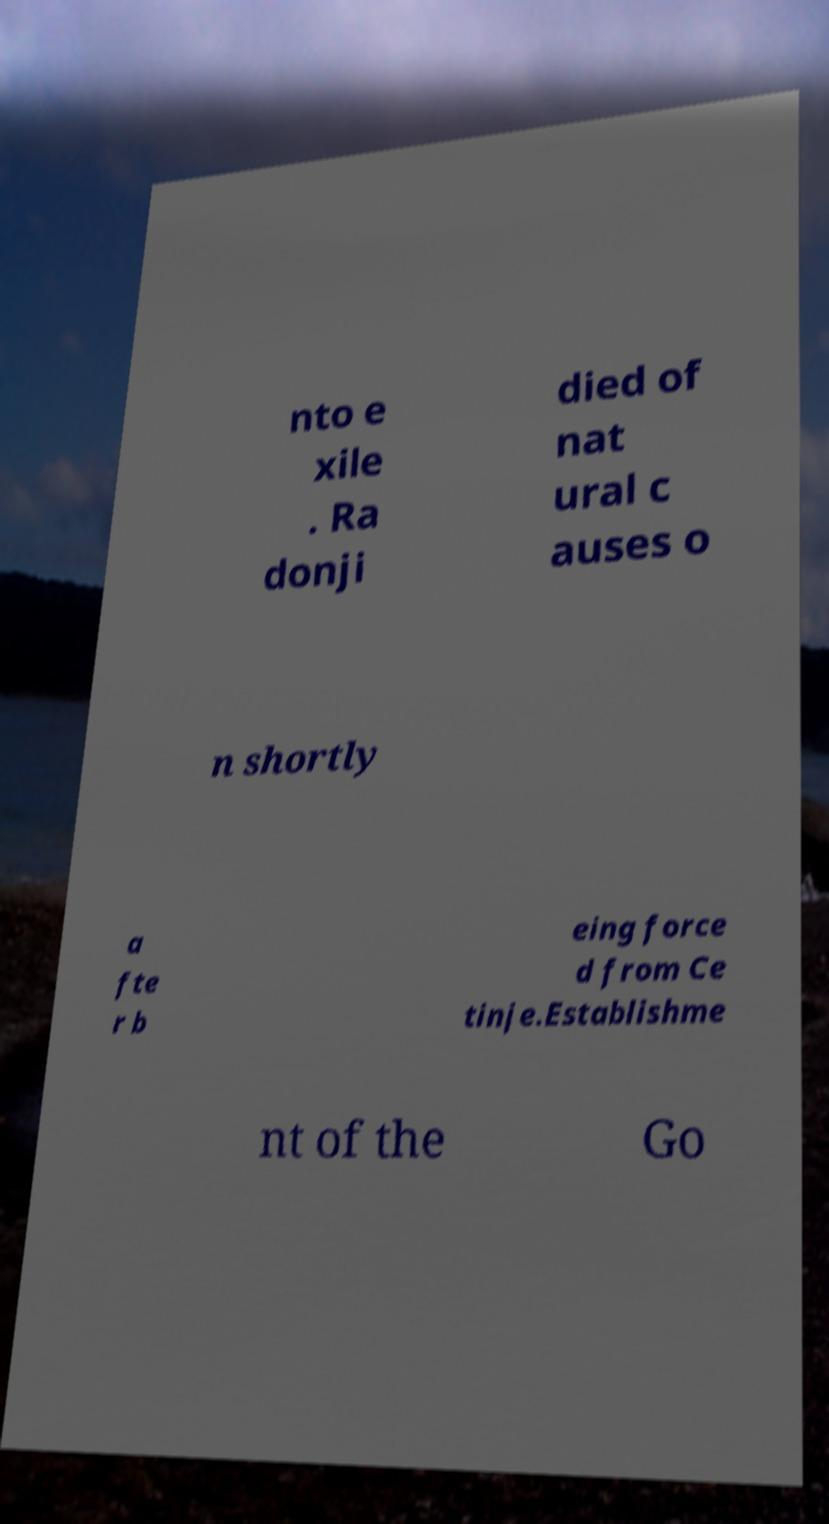Can you read and provide the text displayed in the image?This photo seems to have some interesting text. Can you extract and type it out for me? nto e xile . Ra donji died of nat ural c auses o n shortly a fte r b eing force d from Ce tinje.Establishme nt of the Go 